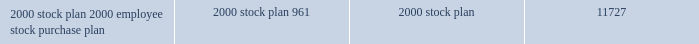Illumina , inc .
Notes to consolidated financial statements 2014 ( continued ) periods .
The price at which stock is purchased under the purchase plan is equal to 85% ( 85 % ) of the fair market value of the common stock on the first or last day of the offering period , whichever is lower .
The initial offering period commenced in july 2000 .
In addition , the purchase plan provides for annual increases of shares available for issuance under the purchase plan beginning with fiscal 2001 .
304714 , 128721 and 64674 shares were issued under the 2000 employee stock purchase plan during fiscal 2003 , 2002 and 2001 , respectively .
Deferred stock compensation since the inception of the company , in connection with the grant of certain stock options and sales of restricted stock to employees , founders and directors through july 25 , 2000 , the company has recorded deferred stock compensation totaling approximately $ 17.7 million , representing the differ- ence between the exercise or purchase price and the fair value of the company 2019s common stock as estimated by the company 2019s management for financial reporting purposes on the date such stock options were granted or restricted common stock was sold .
Deferred compensation is included as a reduction of stockholders 2019 equity and is being amortized to expense over the vesting period of the options and restricted stock .
During the year ended december 28 , 2003 , the company recorded amortization of deferred stock compensation expense of approximately $ 2.5 million .
Shares reserved for future issuance at december 28 , 2003 , the company has reserved shares of common stock for future issuance as follows ( in thousands ) : 2000 stock plan *********************************************************** 10766 2000 employee stock purchase plan***************************************** 961 11727 stockholder rights plan on may 3 , 2001 , the board of directors of the company declared a dividend of one preferred share purchase right ( a 2018 2018right 2019 2019 ) for each outstanding share of common stock of the company .
The dividend was payable on may 14 , 2001 ( the 2018 2018record date 2019 2019 ) to the stockholders of record on that date .
Each right entitles the registered holder to purchase from the company one unit consisting of one- thousandth of a share of its series a junior participating preferred stock at a price of $ 100 per unit .
The rights will be exercisable if a person or group hereafter acquires beneficial ownership of 15% ( 15 % ) or more of the outstanding common stock of the company or announces an offer for 15% ( 15 % ) or more of the outstanding common stock .
If a person or group acquires 15% ( 15 % ) or more of the outstanding common stock of the company , each right will entitle its holder to purchase , at the exercise price of the right , a number of shares of common stock having a market value of two times the exercise price of the right .
If the company is acquired in a merger or other business combination transaction after a person acquires 15% ( 15 % ) or more of the company 2019s common stock , each right will entitle its holder to purchase , at the right 2019s then-current exercise price , a number of common shares of the acquiring company which at the time of such transaction have a market value of two times the exercise price of the right .
The board of directors will be entitled to redeem the rights at a price of $ 0.01 per right at any time before any such person acquires beneficial ownership of 15% ( 15 % ) or more of the outstanding common stock .
The rights expire on may 14 , 2011 unless such date is extended or the rights are earlier redeemed or exchanged by the company. .
Illumina , inc .
Notes to consolidated financial statements 2014 ( continued ) periods .
The price at which stock is purchased under the purchase plan is equal to 85% ( 85 % ) of the fair market value of the common stock on the first or last day of the offering period , whichever is lower .
The initial offering period commenced in july 2000 .
In addition , the purchase plan provides for annual increases of shares available for issuance under the purchase plan beginning with fiscal 2001 .
304714 , 128721 and 64674 shares were issued under the 2000 employee stock purchase plan during fiscal 2003 , 2002 and 2001 , respectively .
Deferred stock compensation since the inception of the company , in connection with the grant of certain stock options and sales of restricted stock to employees , founders and directors through july 25 , 2000 , the company has recorded deferred stock compensation totaling approximately $ 17.7 million , representing the differ- ence between the exercise or purchase price and the fair value of the company 2019s common stock as estimated by the company 2019s management for financial reporting purposes on the date such stock options were granted or restricted common stock was sold .
Deferred compensation is included as a reduction of stockholders 2019 equity and is being amortized to expense over the vesting period of the options and restricted stock .
During the year ended december 28 , 2003 , the company recorded amortization of deferred stock compensation expense of approximately $ 2.5 million .
Shares reserved for future issuance at december 28 , 2003 , the company has reserved shares of common stock for future issuance as follows ( in thousands ) : 2000 stock plan *********************************************************** 10766 2000 employee stock purchase plan***************************************** 961 11727 stockholder rights plan on may 3 , 2001 , the board of directors of the company declared a dividend of one preferred share purchase right ( a 2018 2018right 2019 2019 ) for each outstanding share of common stock of the company .
The dividend was payable on may 14 , 2001 ( the 2018 2018record date 2019 2019 ) to the stockholders of record on that date .
Each right entitles the registered holder to purchase from the company one unit consisting of one- thousandth of a share of its series a junior participating preferred stock at a price of $ 100 per unit .
The rights will be exercisable if a person or group hereafter acquires beneficial ownership of 15% ( 15 % ) or more of the outstanding common stock of the company or announces an offer for 15% ( 15 % ) or more of the outstanding common stock .
If a person or group acquires 15% ( 15 % ) or more of the outstanding common stock of the company , each right will entitle its holder to purchase , at the exercise price of the right , a number of shares of common stock having a market value of two times the exercise price of the right .
If the company is acquired in a merger or other business combination transaction after a person acquires 15% ( 15 % ) or more of the company 2019s common stock , each right will entitle its holder to purchase , at the right 2019s then-current exercise price , a number of common shares of the acquiring company which at the time of such transaction have a market value of two times the exercise price of the right .
The board of directors will be entitled to redeem the rights at a price of $ 0.01 per right at any time before any such person acquires beneficial ownership of 15% ( 15 % ) or more of the outstanding common stock .
The rights expire on may 14 , 2011 unless such date is extended or the rights are earlier redeemed or exchanged by the company. .
What was the percent of the change shares issued under the 2000 employee stock purchase plan from 2002 to 2003? 
Rationale: the shares issued under the 2000 employee stock purchase plan from 2002 to 2003 increased by 137%
Computations: ((304714 - 128721) / 128721)
Answer: 1.36724. 